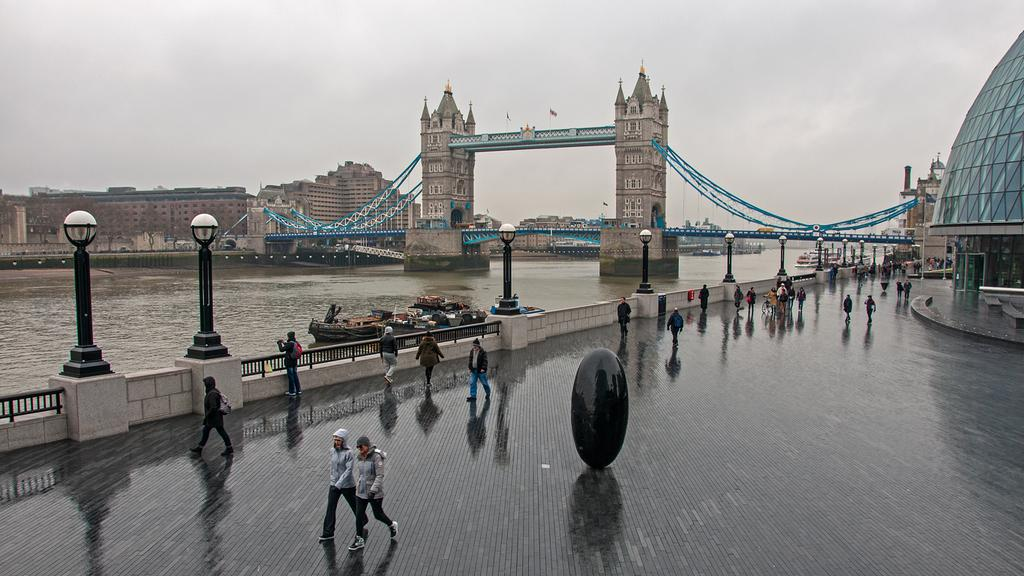What can be seen in the image involving people? There are people standing in the image. What is on the water in the image? There is a boat on the water in the image. What structure is visible behind the boat? There is a bridge behind the boat in the image. What type of buildings can be seen in the image? There are buildings in the left corner of the image. What type of stem can be seen growing from the boat in the image? There is no stem growing from the boat in the image. What kind of board is being used by the people in the image? The image does not show any boards being used by the people. 